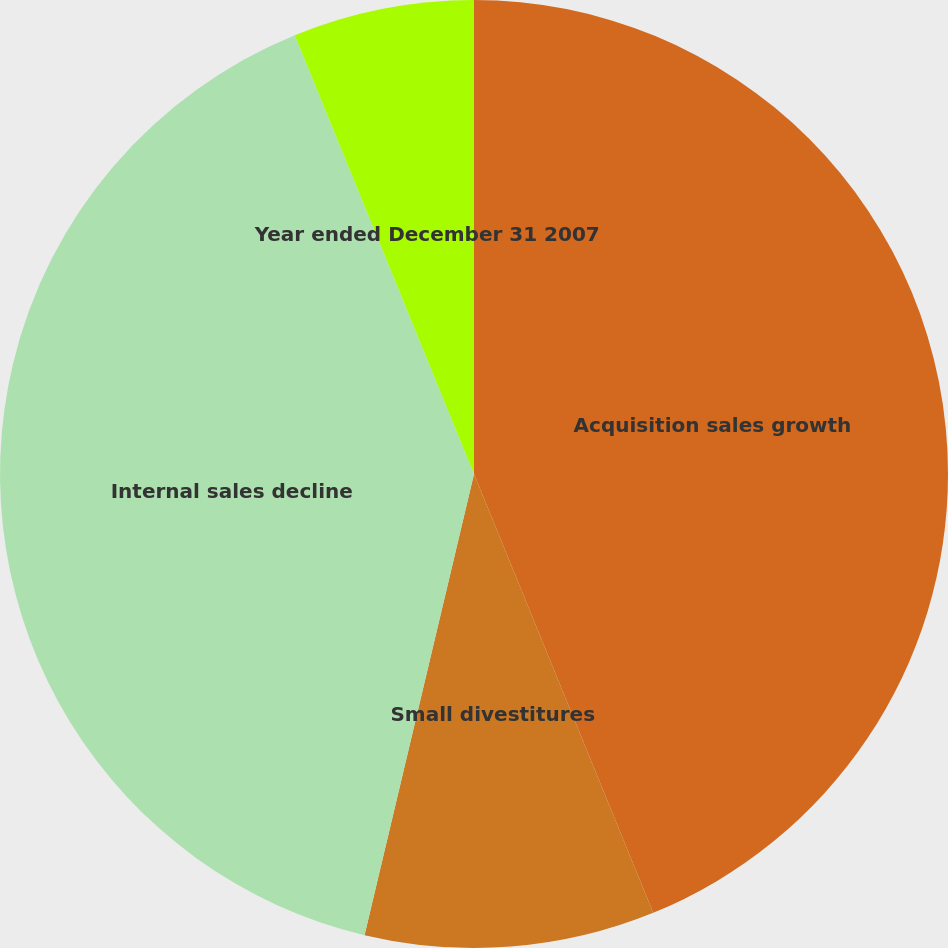Convert chart to OTSL. <chart><loc_0><loc_0><loc_500><loc_500><pie_chart><fcel>Acquisition sales growth<fcel>Small divestitures<fcel>Internal sales decline<fcel>Year ended December 31 2007<nl><fcel>43.83%<fcel>9.88%<fcel>40.12%<fcel>6.17%<nl></chart> 